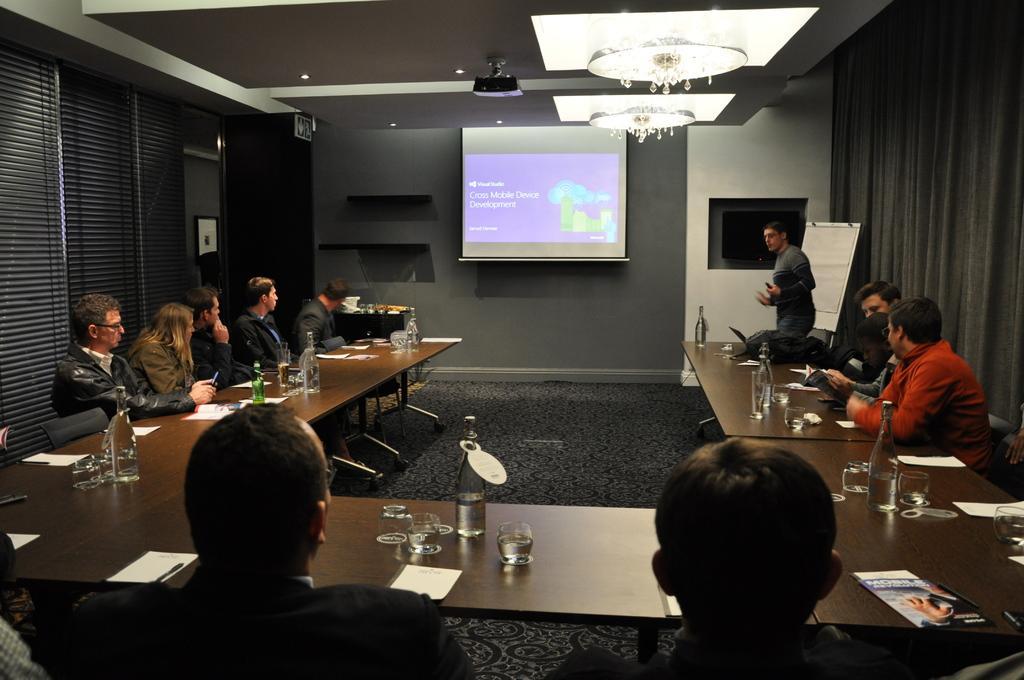Describe this image in one or two sentences. In this image, there are group of people sitting on the chair in front of the table on which bottle, glasses, paper and soon are kept. In the middle of the image, there is a screen. A roof top is grey in color on which a chandelier is fixed. In the left side of the image, there is a window black in color. In the right side of the image, there is a curtain black in color. This image is taken inside a conference hall. 